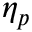<formula> <loc_0><loc_0><loc_500><loc_500>\eta _ { p }</formula> 